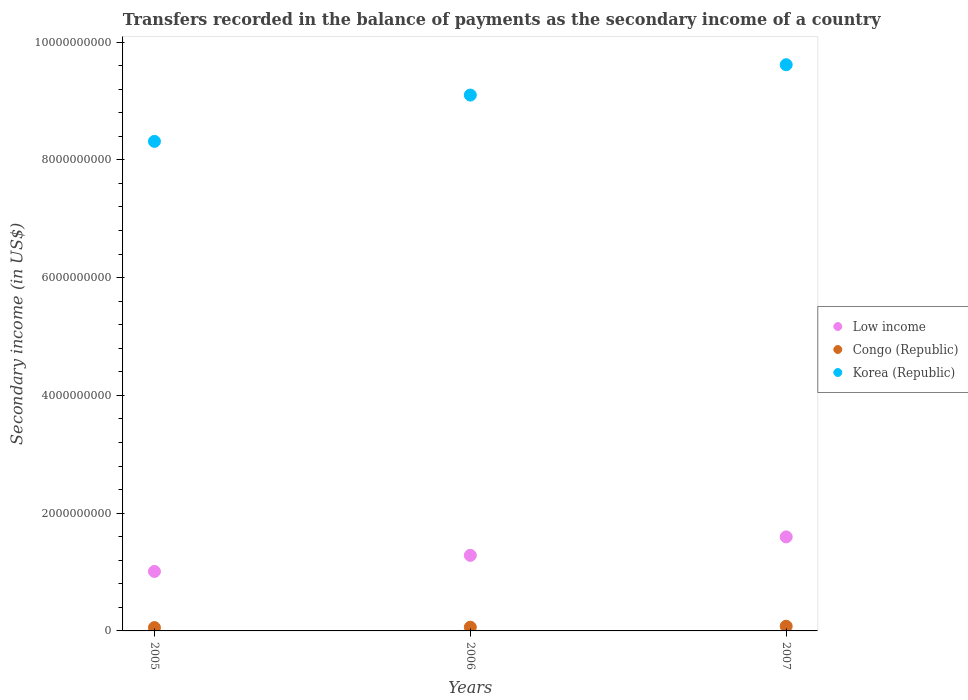What is the secondary income of in Congo (Republic) in 2006?
Make the answer very short. 6.33e+07. Across all years, what is the maximum secondary income of in Korea (Republic)?
Offer a very short reply. 9.62e+09. Across all years, what is the minimum secondary income of in Korea (Republic)?
Offer a terse response. 8.31e+09. What is the total secondary income of in Low income in the graph?
Offer a terse response. 3.89e+09. What is the difference between the secondary income of in Congo (Republic) in 2005 and that in 2007?
Give a very brief answer. -2.30e+07. What is the difference between the secondary income of in Korea (Republic) in 2006 and the secondary income of in Congo (Republic) in 2007?
Your response must be concise. 9.02e+09. What is the average secondary income of in Korea (Republic) per year?
Offer a very short reply. 9.01e+09. In the year 2007, what is the difference between the secondary income of in Korea (Republic) and secondary income of in Low income?
Keep it short and to the point. 8.02e+09. What is the ratio of the secondary income of in Congo (Republic) in 2005 to that in 2006?
Your answer should be very brief. 0.9. Is the difference between the secondary income of in Korea (Republic) in 2005 and 2006 greater than the difference between the secondary income of in Low income in 2005 and 2006?
Offer a terse response. No. What is the difference between the highest and the second highest secondary income of in Korea (Republic)?
Your response must be concise. 5.15e+08. What is the difference between the highest and the lowest secondary income of in Korea (Republic)?
Keep it short and to the point. 1.30e+09. How many years are there in the graph?
Make the answer very short. 3. Are the values on the major ticks of Y-axis written in scientific E-notation?
Offer a terse response. No. Does the graph contain any zero values?
Provide a short and direct response. No. Does the graph contain grids?
Your response must be concise. No. Where does the legend appear in the graph?
Offer a terse response. Center right. What is the title of the graph?
Provide a succinct answer. Transfers recorded in the balance of payments as the secondary income of a country. What is the label or title of the X-axis?
Your answer should be compact. Years. What is the label or title of the Y-axis?
Keep it short and to the point. Secondary income (in US$). What is the Secondary income (in US$) in Low income in 2005?
Offer a very short reply. 1.01e+09. What is the Secondary income (in US$) in Congo (Republic) in 2005?
Keep it short and to the point. 5.67e+07. What is the Secondary income (in US$) in Korea (Republic) in 2005?
Ensure brevity in your answer.  8.31e+09. What is the Secondary income (in US$) of Low income in 2006?
Make the answer very short. 1.28e+09. What is the Secondary income (in US$) in Congo (Republic) in 2006?
Ensure brevity in your answer.  6.33e+07. What is the Secondary income (in US$) in Korea (Republic) in 2006?
Your answer should be very brief. 9.10e+09. What is the Secondary income (in US$) of Low income in 2007?
Your response must be concise. 1.60e+09. What is the Secondary income (in US$) in Congo (Republic) in 2007?
Offer a terse response. 7.97e+07. What is the Secondary income (in US$) in Korea (Republic) in 2007?
Offer a very short reply. 9.62e+09. Across all years, what is the maximum Secondary income (in US$) in Low income?
Your answer should be very brief. 1.60e+09. Across all years, what is the maximum Secondary income (in US$) of Congo (Republic)?
Your response must be concise. 7.97e+07. Across all years, what is the maximum Secondary income (in US$) in Korea (Republic)?
Your response must be concise. 9.62e+09. Across all years, what is the minimum Secondary income (in US$) in Low income?
Your response must be concise. 1.01e+09. Across all years, what is the minimum Secondary income (in US$) of Congo (Republic)?
Offer a terse response. 5.67e+07. Across all years, what is the minimum Secondary income (in US$) in Korea (Republic)?
Offer a very short reply. 8.31e+09. What is the total Secondary income (in US$) of Low income in the graph?
Offer a terse response. 3.89e+09. What is the total Secondary income (in US$) of Congo (Republic) in the graph?
Provide a succinct answer. 2.00e+08. What is the total Secondary income (in US$) of Korea (Republic) in the graph?
Your answer should be very brief. 2.70e+1. What is the difference between the Secondary income (in US$) of Low income in 2005 and that in 2006?
Offer a terse response. -2.73e+08. What is the difference between the Secondary income (in US$) in Congo (Republic) in 2005 and that in 2006?
Make the answer very short. -6.62e+06. What is the difference between the Secondary income (in US$) in Korea (Republic) in 2005 and that in 2006?
Give a very brief answer. -7.86e+08. What is the difference between the Secondary income (in US$) of Low income in 2005 and that in 2007?
Make the answer very short. -5.87e+08. What is the difference between the Secondary income (in US$) of Congo (Republic) in 2005 and that in 2007?
Provide a short and direct response. -2.30e+07. What is the difference between the Secondary income (in US$) in Korea (Republic) in 2005 and that in 2007?
Provide a short and direct response. -1.30e+09. What is the difference between the Secondary income (in US$) in Low income in 2006 and that in 2007?
Make the answer very short. -3.13e+08. What is the difference between the Secondary income (in US$) in Congo (Republic) in 2006 and that in 2007?
Offer a terse response. -1.64e+07. What is the difference between the Secondary income (in US$) of Korea (Republic) in 2006 and that in 2007?
Keep it short and to the point. -5.15e+08. What is the difference between the Secondary income (in US$) in Low income in 2005 and the Secondary income (in US$) in Congo (Republic) in 2006?
Offer a very short reply. 9.47e+08. What is the difference between the Secondary income (in US$) in Low income in 2005 and the Secondary income (in US$) in Korea (Republic) in 2006?
Offer a very short reply. -8.09e+09. What is the difference between the Secondary income (in US$) of Congo (Republic) in 2005 and the Secondary income (in US$) of Korea (Republic) in 2006?
Offer a terse response. -9.04e+09. What is the difference between the Secondary income (in US$) in Low income in 2005 and the Secondary income (in US$) in Congo (Republic) in 2007?
Your answer should be very brief. 9.30e+08. What is the difference between the Secondary income (in US$) of Low income in 2005 and the Secondary income (in US$) of Korea (Republic) in 2007?
Provide a short and direct response. -8.61e+09. What is the difference between the Secondary income (in US$) in Congo (Republic) in 2005 and the Secondary income (in US$) in Korea (Republic) in 2007?
Ensure brevity in your answer.  -9.56e+09. What is the difference between the Secondary income (in US$) of Low income in 2006 and the Secondary income (in US$) of Congo (Republic) in 2007?
Provide a succinct answer. 1.20e+09. What is the difference between the Secondary income (in US$) of Low income in 2006 and the Secondary income (in US$) of Korea (Republic) in 2007?
Offer a very short reply. -8.33e+09. What is the difference between the Secondary income (in US$) of Congo (Republic) in 2006 and the Secondary income (in US$) of Korea (Republic) in 2007?
Offer a very short reply. -9.55e+09. What is the average Secondary income (in US$) of Low income per year?
Your answer should be compact. 1.30e+09. What is the average Secondary income (in US$) in Congo (Republic) per year?
Offer a very short reply. 6.66e+07. What is the average Secondary income (in US$) of Korea (Republic) per year?
Give a very brief answer. 9.01e+09. In the year 2005, what is the difference between the Secondary income (in US$) of Low income and Secondary income (in US$) of Congo (Republic)?
Keep it short and to the point. 9.53e+08. In the year 2005, what is the difference between the Secondary income (in US$) of Low income and Secondary income (in US$) of Korea (Republic)?
Your response must be concise. -7.30e+09. In the year 2005, what is the difference between the Secondary income (in US$) of Congo (Republic) and Secondary income (in US$) of Korea (Republic)?
Keep it short and to the point. -8.26e+09. In the year 2006, what is the difference between the Secondary income (in US$) of Low income and Secondary income (in US$) of Congo (Republic)?
Make the answer very short. 1.22e+09. In the year 2006, what is the difference between the Secondary income (in US$) in Low income and Secondary income (in US$) in Korea (Republic)?
Your response must be concise. -7.82e+09. In the year 2006, what is the difference between the Secondary income (in US$) in Congo (Republic) and Secondary income (in US$) in Korea (Republic)?
Your answer should be very brief. -9.04e+09. In the year 2007, what is the difference between the Secondary income (in US$) of Low income and Secondary income (in US$) of Congo (Republic)?
Ensure brevity in your answer.  1.52e+09. In the year 2007, what is the difference between the Secondary income (in US$) of Low income and Secondary income (in US$) of Korea (Republic)?
Your answer should be compact. -8.02e+09. In the year 2007, what is the difference between the Secondary income (in US$) of Congo (Republic) and Secondary income (in US$) of Korea (Republic)?
Give a very brief answer. -9.54e+09. What is the ratio of the Secondary income (in US$) of Low income in 2005 to that in 2006?
Provide a succinct answer. 0.79. What is the ratio of the Secondary income (in US$) in Congo (Republic) in 2005 to that in 2006?
Offer a terse response. 0.9. What is the ratio of the Secondary income (in US$) of Korea (Republic) in 2005 to that in 2006?
Provide a short and direct response. 0.91. What is the ratio of the Secondary income (in US$) in Low income in 2005 to that in 2007?
Make the answer very short. 0.63. What is the ratio of the Secondary income (in US$) in Congo (Republic) in 2005 to that in 2007?
Make the answer very short. 0.71. What is the ratio of the Secondary income (in US$) of Korea (Republic) in 2005 to that in 2007?
Provide a succinct answer. 0.86. What is the ratio of the Secondary income (in US$) of Low income in 2006 to that in 2007?
Keep it short and to the point. 0.8. What is the ratio of the Secondary income (in US$) in Congo (Republic) in 2006 to that in 2007?
Your answer should be compact. 0.79. What is the ratio of the Secondary income (in US$) in Korea (Republic) in 2006 to that in 2007?
Provide a succinct answer. 0.95. What is the difference between the highest and the second highest Secondary income (in US$) of Low income?
Make the answer very short. 3.13e+08. What is the difference between the highest and the second highest Secondary income (in US$) of Congo (Republic)?
Provide a short and direct response. 1.64e+07. What is the difference between the highest and the second highest Secondary income (in US$) in Korea (Republic)?
Your response must be concise. 5.15e+08. What is the difference between the highest and the lowest Secondary income (in US$) of Low income?
Keep it short and to the point. 5.87e+08. What is the difference between the highest and the lowest Secondary income (in US$) in Congo (Republic)?
Offer a very short reply. 2.30e+07. What is the difference between the highest and the lowest Secondary income (in US$) of Korea (Republic)?
Keep it short and to the point. 1.30e+09. 